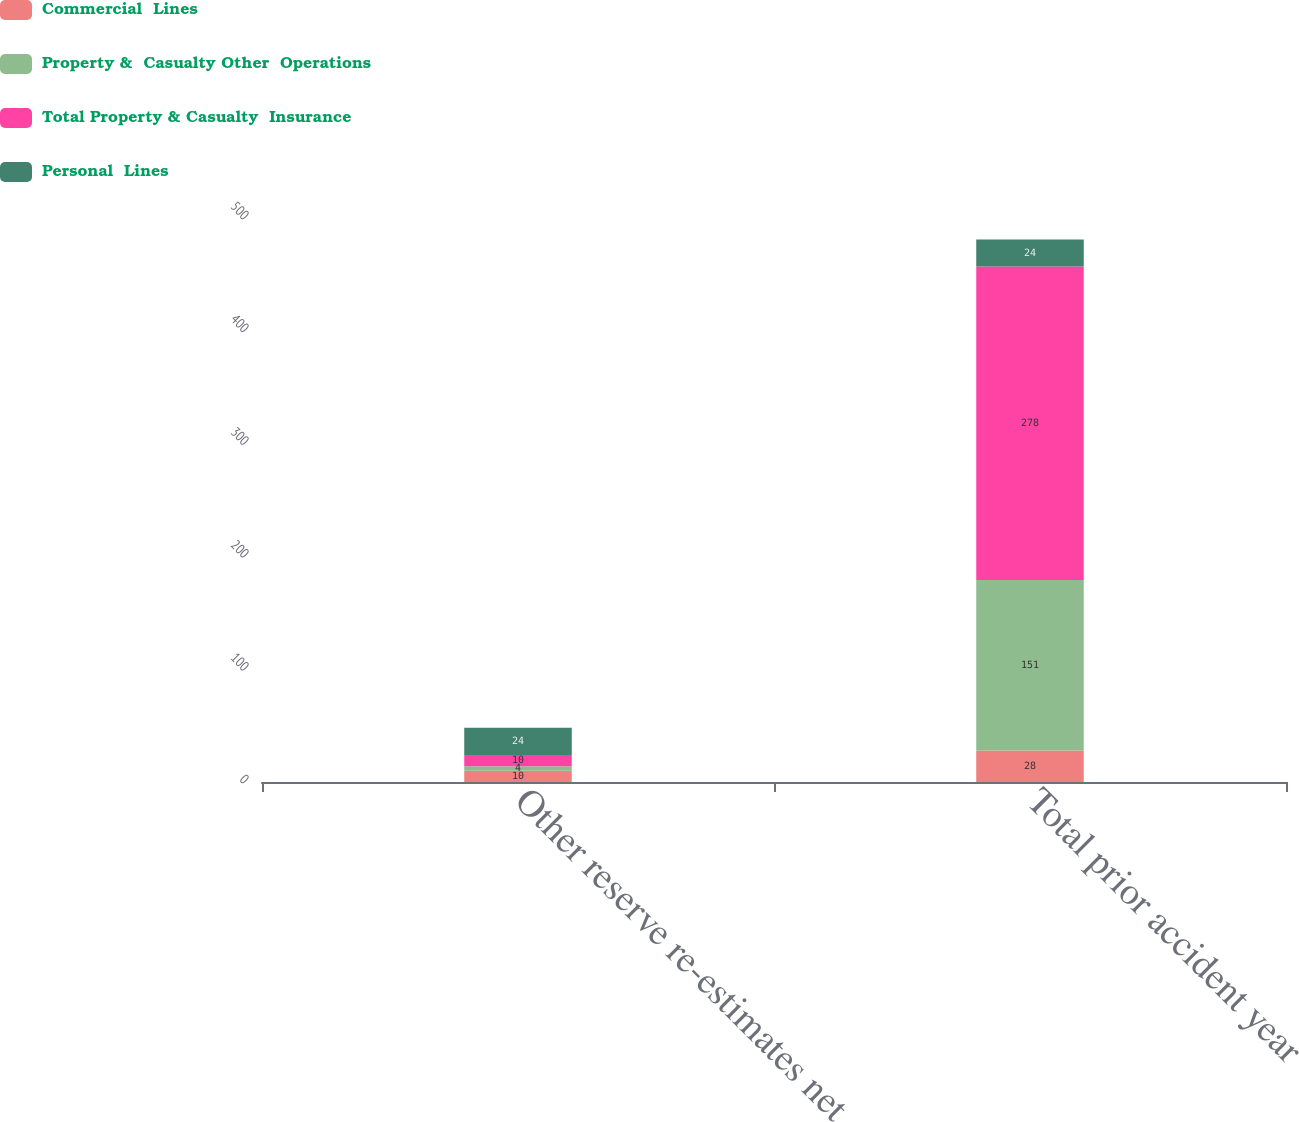Convert chart to OTSL. <chart><loc_0><loc_0><loc_500><loc_500><stacked_bar_chart><ecel><fcel>Other reserve re-estimates net<fcel>Total prior accident year<nl><fcel>Commercial  Lines<fcel>10<fcel>28<nl><fcel>Property &  Casualty Other  Operations<fcel>4<fcel>151<nl><fcel>Total Property & Casualty  Insurance<fcel>10<fcel>278<nl><fcel>Personal  Lines<fcel>24<fcel>24<nl></chart> 